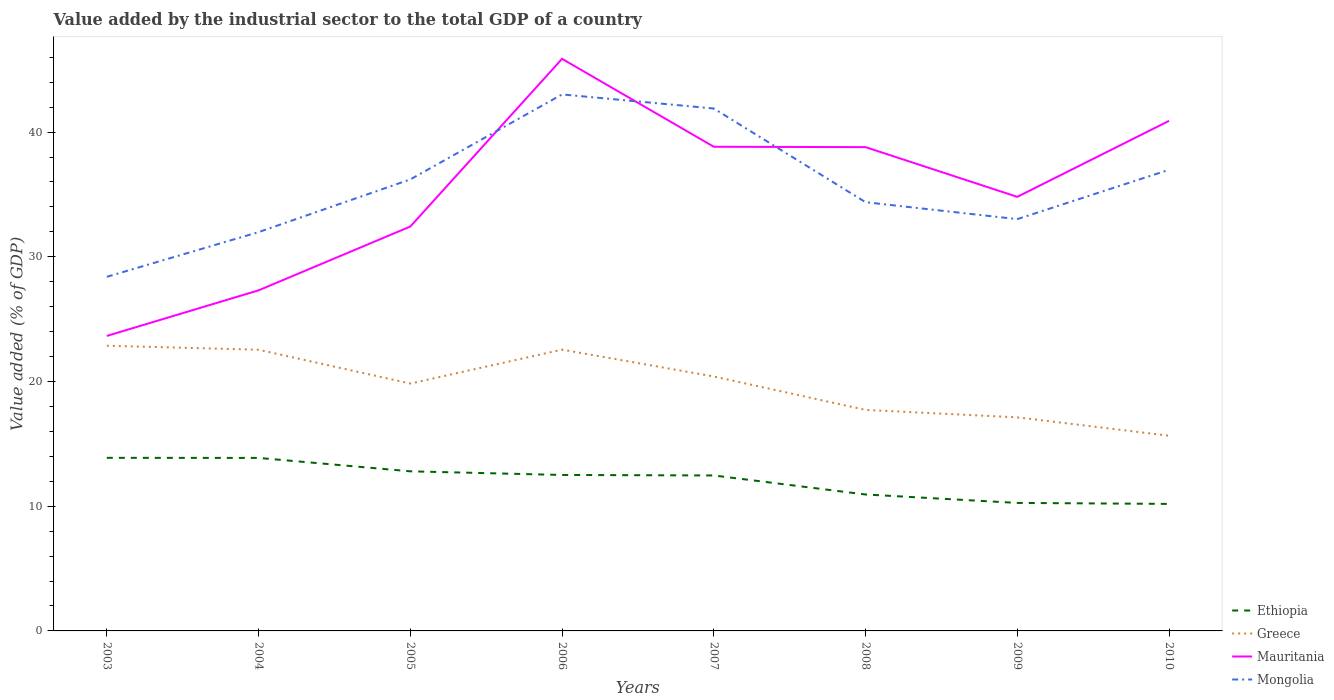Does the line corresponding to Ethiopia intersect with the line corresponding to Mauritania?
Provide a short and direct response. No. Is the number of lines equal to the number of legend labels?
Your answer should be compact. Yes. Across all years, what is the maximum value added by the industrial sector to the total GDP in Mauritania?
Provide a short and direct response. 23.66. In which year was the value added by the industrial sector to the total GDP in Mauritania maximum?
Provide a short and direct response. 2003. What is the total value added by the industrial sector to the total GDP in Greece in the graph?
Give a very brief answer. 0.31. What is the difference between the highest and the second highest value added by the industrial sector to the total GDP in Greece?
Offer a terse response. 7.21. What is the difference between two consecutive major ticks on the Y-axis?
Provide a succinct answer. 10. Does the graph contain any zero values?
Give a very brief answer. No. Where does the legend appear in the graph?
Offer a terse response. Bottom right. How many legend labels are there?
Your answer should be compact. 4. What is the title of the graph?
Ensure brevity in your answer.  Value added by the industrial sector to the total GDP of a country. Does "Romania" appear as one of the legend labels in the graph?
Offer a terse response. No. What is the label or title of the Y-axis?
Keep it short and to the point. Value added (% of GDP). What is the Value added (% of GDP) of Ethiopia in 2003?
Offer a terse response. 13.88. What is the Value added (% of GDP) of Greece in 2003?
Offer a very short reply. 22.87. What is the Value added (% of GDP) in Mauritania in 2003?
Your response must be concise. 23.66. What is the Value added (% of GDP) of Mongolia in 2003?
Provide a short and direct response. 28.4. What is the Value added (% of GDP) of Ethiopia in 2004?
Keep it short and to the point. 13.87. What is the Value added (% of GDP) in Greece in 2004?
Your answer should be very brief. 22.55. What is the Value added (% of GDP) of Mauritania in 2004?
Your answer should be compact. 27.31. What is the Value added (% of GDP) in Mongolia in 2004?
Offer a terse response. 31.98. What is the Value added (% of GDP) of Ethiopia in 2005?
Your answer should be very brief. 12.8. What is the Value added (% of GDP) in Greece in 2005?
Your response must be concise. 19.84. What is the Value added (% of GDP) in Mauritania in 2005?
Offer a very short reply. 32.43. What is the Value added (% of GDP) in Mongolia in 2005?
Offer a very short reply. 36.21. What is the Value added (% of GDP) of Ethiopia in 2006?
Your answer should be very brief. 12.51. What is the Value added (% of GDP) in Greece in 2006?
Make the answer very short. 22.56. What is the Value added (% of GDP) in Mauritania in 2006?
Ensure brevity in your answer.  45.88. What is the Value added (% of GDP) of Mongolia in 2006?
Make the answer very short. 43.02. What is the Value added (% of GDP) of Ethiopia in 2007?
Offer a very short reply. 12.47. What is the Value added (% of GDP) of Greece in 2007?
Offer a very short reply. 20.4. What is the Value added (% of GDP) in Mauritania in 2007?
Ensure brevity in your answer.  38.82. What is the Value added (% of GDP) in Mongolia in 2007?
Offer a terse response. 41.89. What is the Value added (% of GDP) of Ethiopia in 2008?
Make the answer very short. 10.94. What is the Value added (% of GDP) in Greece in 2008?
Keep it short and to the point. 17.72. What is the Value added (% of GDP) of Mauritania in 2008?
Provide a short and direct response. 38.8. What is the Value added (% of GDP) in Mongolia in 2008?
Provide a short and direct response. 34.38. What is the Value added (% of GDP) in Ethiopia in 2009?
Keep it short and to the point. 10.26. What is the Value added (% of GDP) in Greece in 2009?
Offer a very short reply. 17.13. What is the Value added (% of GDP) of Mauritania in 2009?
Offer a very short reply. 34.81. What is the Value added (% of GDP) of Mongolia in 2009?
Give a very brief answer. 33.02. What is the Value added (% of GDP) of Ethiopia in 2010?
Provide a short and direct response. 10.19. What is the Value added (% of GDP) in Greece in 2010?
Keep it short and to the point. 15.66. What is the Value added (% of GDP) in Mauritania in 2010?
Your response must be concise. 40.9. What is the Value added (% of GDP) in Mongolia in 2010?
Ensure brevity in your answer.  36.98. Across all years, what is the maximum Value added (% of GDP) of Ethiopia?
Keep it short and to the point. 13.88. Across all years, what is the maximum Value added (% of GDP) in Greece?
Provide a succinct answer. 22.87. Across all years, what is the maximum Value added (% of GDP) of Mauritania?
Offer a terse response. 45.88. Across all years, what is the maximum Value added (% of GDP) in Mongolia?
Offer a terse response. 43.02. Across all years, what is the minimum Value added (% of GDP) in Ethiopia?
Your answer should be very brief. 10.19. Across all years, what is the minimum Value added (% of GDP) of Greece?
Your answer should be very brief. 15.66. Across all years, what is the minimum Value added (% of GDP) in Mauritania?
Keep it short and to the point. 23.66. Across all years, what is the minimum Value added (% of GDP) in Mongolia?
Provide a short and direct response. 28.4. What is the total Value added (% of GDP) of Ethiopia in the graph?
Your answer should be very brief. 96.92. What is the total Value added (% of GDP) in Greece in the graph?
Make the answer very short. 158.72. What is the total Value added (% of GDP) of Mauritania in the graph?
Make the answer very short. 282.6. What is the total Value added (% of GDP) of Mongolia in the graph?
Make the answer very short. 285.88. What is the difference between the Value added (% of GDP) of Ethiopia in 2003 and that in 2004?
Your answer should be compact. 0.01. What is the difference between the Value added (% of GDP) of Greece in 2003 and that in 2004?
Your answer should be very brief. 0.32. What is the difference between the Value added (% of GDP) in Mauritania in 2003 and that in 2004?
Ensure brevity in your answer.  -3.66. What is the difference between the Value added (% of GDP) in Mongolia in 2003 and that in 2004?
Ensure brevity in your answer.  -3.58. What is the difference between the Value added (% of GDP) in Ethiopia in 2003 and that in 2005?
Provide a short and direct response. 1.08. What is the difference between the Value added (% of GDP) of Greece in 2003 and that in 2005?
Offer a terse response. 3.03. What is the difference between the Value added (% of GDP) in Mauritania in 2003 and that in 2005?
Keep it short and to the point. -8.77. What is the difference between the Value added (% of GDP) of Mongolia in 2003 and that in 2005?
Make the answer very short. -7.81. What is the difference between the Value added (% of GDP) of Ethiopia in 2003 and that in 2006?
Make the answer very short. 1.37. What is the difference between the Value added (% of GDP) of Greece in 2003 and that in 2006?
Make the answer very short. 0.31. What is the difference between the Value added (% of GDP) of Mauritania in 2003 and that in 2006?
Your response must be concise. -22.22. What is the difference between the Value added (% of GDP) in Mongolia in 2003 and that in 2006?
Your answer should be very brief. -14.62. What is the difference between the Value added (% of GDP) in Ethiopia in 2003 and that in 2007?
Your answer should be compact. 1.41. What is the difference between the Value added (% of GDP) of Greece in 2003 and that in 2007?
Provide a short and direct response. 2.47. What is the difference between the Value added (% of GDP) of Mauritania in 2003 and that in 2007?
Offer a terse response. -15.17. What is the difference between the Value added (% of GDP) in Mongolia in 2003 and that in 2007?
Offer a terse response. -13.5. What is the difference between the Value added (% of GDP) in Ethiopia in 2003 and that in 2008?
Ensure brevity in your answer.  2.94. What is the difference between the Value added (% of GDP) of Greece in 2003 and that in 2008?
Keep it short and to the point. 5.15. What is the difference between the Value added (% of GDP) in Mauritania in 2003 and that in 2008?
Your answer should be compact. -15.14. What is the difference between the Value added (% of GDP) in Mongolia in 2003 and that in 2008?
Offer a terse response. -5.98. What is the difference between the Value added (% of GDP) in Ethiopia in 2003 and that in 2009?
Offer a terse response. 3.62. What is the difference between the Value added (% of GDP) in Greece in 2003 and that in 2009?
Your answer should be compact. 5.74. What is the difference between the Value added (% of GDP) in Mauritania in 2003 and that in 2009?
Provide a succinct answer. -11.15. What is the difference between the Value added (% of GDP) of Mongolia in 2003 and that in 2009?
Your answer should be compact. -4.63. What is the difference between the Value added (% of GDP) of Ethiopia in 2003 and that in 2010?
Keep it short and to the point. 3.7. What is the difference between the Value added (% of GDP) of Greece in 2003 and that in 2010?
Ensure brevity in your answer.  7.21. What is the difference between the Value added (% of GDP) of Mauritania in 2003 and that in 2010?
Your answer should be compact. -17.25. What is the difference between the Value added (% of GDP) in Mongolia in 2003 and that in 2010?
Ensure brevity in your answer.  -8.58. What is the difference between the Value added (% of GDP) of Ethiopia in 2004 and that in 2005?
Ensure brevity in your answer.  1.07. What is the difference between the Value added (% of GDP) of Greece in 2004 and that in 2005?
Your response must be concise. 2.71. What is the difference between the Value added (% of GDP) of Mauritania in 2004 and that in 2005?
Your answer should be very brief. -5.12. What is the difference between the Value added (% of GDP) in Mongolia in 2004 and that in 2005?
Your response must be concise. -4.23. What is the difference between the Value added (% of GDP) in Ethiopia in 2004 and that in 2006?
Keep it short and to the point. 1.37. What is the difference between the Value added (% of GDP) of Greece in 2004 and that in 2006?
Provide a short and direct response. -0.01. What is the difference between the Value added (% of GDP) of Mauritania in 2004 and that in 2006?
Your answer should be very brief. -18.57. What is the difference between the Value added (% of GDP) of Mongolia in 2004 and that in 2006?
Provide a short and direct response. -11.04. What is the difference between the Value added (% of GDP) of Ethiopia in 2004 and that in 2007?
Provide a succinct answer. 1.41. What is the difference between the Value added (% of GDP) in Greece in 2004 and that in 2007?
Offer a terse response. 2.15. What is the difference between the Value added (% of GDP) of Mauritania in 2004 and that in 2007?
Provide a succinct answer. -11.51. What is the difference between the Value added (% of GDP) of Mongolia in 2004 and that in 2007?
Make the answer very short. -9.91. What is the difference between the Value added (% of GDP) in Ethiopia in 2004 and that in 2008?
Offer a very short reply. 2.93. What is the difference between the Value added (% of GDP) of Greece in 2004 and that in 2008?
Provide a succinct answer. 4.83. What is the difference between the Value added (% of GDP) in Mauritania in 2004 and that in 2008?
Offer a very short reply. -11.48. What is the difference between the Value added (% of GDP) of Mongolia in 2004 and that in 2008?
Ensure brevity in your answer.  -2.4. What is the difference between the Value added (% of GDP) of Ethiopia in 2004 and that in 2009?
Keep it short and to the point. 3.61. What is the difference between the Value added (% of GDP) of Greece in 2004 and that in 2009?
Provide a short and direct response. 5.42. What is the difference between the Value added (% of GDP) in Mauritania in 2004 and that in 2009?
Your response must be concise. -7.5. What is the difference between the Value added (% of GDP) of Mongolia in 2004 and that in 2009?
Provide a succinct answer. -1.04. What is the difference between the Value added (% of GDP) in Ethiopia in 2004 and that in 2010?
Offer a very short reply. 3.69. What is the difference between the Value added (% of GDP) in Greece in 2004 and that in 2010?
Provide a short and direct response. 6.89. What is the difference between the Value added (% of GDP) in Mauritania in 2004 and that in 2010?
Offer a terse response. -13.59. What is the difference between the Value added (% of GDP) in Mongolia in 2004 and that in 2010?
Provide a short and direct response. -5. What is the difference between the Value added (% of GDP) in Ethiopia in 2005 and that in 2006?
Provide a succinct answer. 0.29. What is the difference between the Value added (% of GDP) of Greece in 2005 and that in 2006?
Your response must be concise. -2.72. What is the difference between the Value added (% of GDP) in Mauritania in 2005 and that in 2006?
Offer a very short reply. -13.45. What is the difference between the Value added (% of GDP) in Mongolia in 2005 and that in 2006?
Your answer should be very brief. -6.81. What is the difference between the Value added (% of GDP) in Ethiopia in 2005 and that in 2007?
Ensure brevity in your answer.  0.33. What is the difference between the Value added (% of GDP) in Greece in 2005 and that in 2007?
Offer a terse response. -0.57. What is the difference between the Value added (% of GDP) of Mauritania in 2005 and that in 2007?
Offer a very short reply. -6.4. What is the difference between the Value added (% of GDP) in Mongolia in 2005 and that in 2007?
Give a very brief answer. -5.68. What is the difference between the Value added (% of GDP) in Ethiopia in 2005 and that in 2008?
Provide a short and direct response. 1.86. What is the difference between the Value added (% of GDP) in Greece in 2005 and that in 2008?
Make the answer very short. 2.11. What is the difference between the Value added (% of GDP) of Mauritania in 2005 and that in 2008?
Keep it short and to the point. -6.37. What is the difference between the Value added (% of GDP) of Mongolia in 2005 and that in 2008?
Offer a terse response. 1.83. What is the difference between the Value added (% of GDP) of Ethiopia in 2005 and that in 2009?
Your response must be concise. 2.53. What is the difference between the Value added (% of GDP) in Greece in 2005 and that in 2009?
Your response must be concise. 2.71. What is the difference between the Value added (% of GDP) of Mauritania in 2005 and that in 2009?
Give a very brief answer. -2.38. What is the difference between the Value added (% of GDP) of Mongolia in 2005 and that in 2009?
Provide a short and direct response. 3.19. What is the difference between the Value added (% of GDP) of Ethiopia in 2005 and that in 2010?
Your answer should be compact. 2.61. What is the difference between the Value added (% of GDP) in Greece in 2005 and that in 2010?
Offer a very short reply. 4.18. What is the difference between the Value added (% of GDP) in Mauritania in 2005 and that in 2010?
Offer a terse response. -8.47. What is the difference between the Value added (% of GDP) of Mongolia in 2005 and that in 2010?
Offer a very short reply. -0.77. What is the difference between the Value added (% of GDP) of Ethiopia in 2006 and that in 2007?
Make the answer very short. 0.04. What is the difference between the Value added (% of GDP) of Greece in 2006 and that in 2007?
Your answer should be compact. 2.15. What is the difference between the Value added (% of GDP) in Mauritania in 2006 and that in 2007?
Offer a very short reply. 7.05. What is the difference between the Value added (% of GDP) in Mongolia in 2006 and that in 2007?
Ensure brevity in your answer.  1.13. What is the difference between the Value added (% of GDP) of Ethiopia in 2006 and that in 2008?
Offer a terse response. 1.57. What is the difference between the Value added (% of GDP) in Greece in 2006 and that in 2008?
Make the answer very short. 4.83. What is the difference between the Value added (% of GDP) of Mauritania in 2006 and that in 2008?
Provide a short and direct response. 7.08. What is the difference between the Value added (% of GDP) in Mongolia in 2006 and that in 2008?
Ensure brevity in your answer.  8.64. What is the difference between the Value added (% of GDP) of Ethiopia in 2006 and that in 2009?
Offer a very short reply. 2.24. What is the difference between the Value added (% of GDP) of Greece in 2006 and that in 2009?
Keep it short and to the point. 5.43. What is the difference between the Value added (% of GDP) in Mauritania in 2006 and that in 2009?
Your answer should be compact. 11.07. What is the difference between the Value added (% of GDP) in Mongolia in 2006 and that in 2009?
Provide a short and direct response. 10. What is the difference between the Value added (% of GDP) of Ethiopia in 2006 and that in 2010?
Offer a terse response. 2.32. What is the difference between the Value added (% of GDP) of Greece in 2006 and that in 2010?
Offer a very short reply. 6.9. What is the difference between the Value added (% of GDP) in Mauritania in 2006 and that in 2010?
Your answer should be compact. 4.97. What is the difference between the Value added (% of GDP) of Mongolia in 2006 and that in 2010?
Offer a terse response. 6.04. What is the difference between the Value added (% of GDP) in Ethiopia in 2007 and that in 2008?
Your answer should be very brief. 1.53. What is the difference between the Value added (% of GDP) of Greece in 2007 and that in 2008?
Provide a short and direct response. 2.68. What is the difference between the Value added (% of GDP) of Mauritania in 2007 and that in 2008?
Give a very brief answer. 0.03. What is the difference between the Value added (% of GDP) of Mongolia in 2007 and that in 2008?
Keep it short and to the point. 7.51. What is the difference between the Value added (% of GDP) of Ethiopia in 2007 and that in 2009?
Offer a terse response. 2.2. What is the difference between the Value added (% of GDP) in Greece in 2007 and that in 2009?
Provide a succinct answer. 3.28. What is the difference between the Value added (% of GDP) in Mauritania in 2007 and that in 2009?
Keep it short and to the point. 4.02. What is the difference between the Value added (% of GDP) of Mongolia in 2007 and that in 2009?
Provide a succinct answer. 8.87. What is the difference between the Value added (% of GDP) in Ethiopia in 2007 and that in 2010?
Your answer should be very brief. 2.28. What is the difference between the Value added (% of GDP) in Greece in 2007 and that in 2010?
Give a very brief answer. 4.75. What is the difference between the Value added (% of GDP) in Mauritania in 2007 and that in 2010?
Your answer should be very brief. -2.08. What is the difference between the Value added (% of GDP) in Mongolia in 2007 and that in 2010?
Provide a succinct answer. 4.91. What is the difference between the Value added (% of GDP) of Ethiopia in 2008 and that in 2009?
Keep it short and to the point. 0.68. What is the difference between the Value added (% of GDP) in Greece in 2008 and that in 2009?
Offer a terse response. 0.6. What is the difference between the Value added (% of GDP) in Mauritania in 2008 and that in 2009?
Your answer should be compact. 3.99. What is the difference between the Value added (% of GDP) in Mongolia in 2008 and that in 2009?
Offer a very short reply. 1.36. What is the difference between the Value added (% of GDP) in Ethiopia in 2008 and that in 2010?
Ensure brevity in your answer.  0.76. What is the difference between the Value added (% of GDP) in Greece in 2008 and that in 2010?
Offer a very short reply. 2.07. What is the difference between the Value added (% of GDP) of Mauritania in 2008 and that in 2010?
Your answer should be compact. -2.11. What is the difference between the Value added (% of GDP) in Mongolia in 2008 and that in 2010?
Offer a terse response. -2.6. What is the difference between the Value added (% of GDP) in Ethiopia in 2009 and that in 2010?
Give a very brief answer. 0.08. What is the difference between the Value added (% of GDP) in Greece in 2009 and that in 2010?
Give a very brief answer. 1.47. What is the difference between the Value added (% of GDP) in Mauritania in 2009 and that in 2010?
Ensure brevity in your answer.  -6.1. What is the difference between the Value added (% of GDP) in Mongolia in 2009 and that in 2010?
Your answer should be compact. -3.96. What is the difference between the Value added (% of GDP) in Ethiopia in 2003 and the Value added (% of GDP) in Greece in 2004?
Ensure brevity in your answer.  -8.67. What is the difference between the Value added (% of GDP) of Ethiopia in 2003 and the Value added (% of GDP) of Mauritania in 2004?
Offer a terse response. -13.43. What is the difference between the Value added (% of GDP) of Ethiopia in 2003 and the Value added (% of GDP) of Mongolia in 2004?
Ensure brevity in your answer.  -18.1. What is the difference between the Value added (% of GDP) in Greece in 2003 and the Value added (% of GDP) in Mauritania in 2004?
Give a very brief answer. -4.44. What is the difference between the Value added (% of GDP) of Greece in 2003 and the Value added (% of GDP) of Mongolia in 2004?
Offer a terse response. -9.11. What is the difference between the Value added (% of GDP) in Mauritania in 2003 and the Value added (% of GDP) in Mongolia in 2004?
Ensure brevity in your answer.  -8.32. What is the difference between the Value added (% of GDP) in Ethiopia in 2003 and the Value added (% of GDP) in Greece in 2005?
Ensure brevity in your answer.  -5.96. What is the difference between the Value added (% of GDP) in Ethiopia in 2003 and the Value added (% of GDP) in Mauritania in 2005?
Provide a succinct answer. -18.55. What is the difference between the Value added (% of GDP) of Ethiopia in 2003 and the Value added (% of GDP) of Mongolia in 2005?
Provide a succinct answer. -22.33. What is the difference between the Value added (% of GDP) of Greece in 2003 and the Value added (% of GDP) of Mauritania in 2005?
Provide a succinct answer. -9.56. What is the difference between the Value added (% of GDP) of Greece in 2003 and the Value added (% of GDP) of Mongolia in 2005?
Give a very brief answer. -13.34. What is the difference between the Value added (% of GDP) in Mauritania in 2003 and the Value added (% of GDP) in Mongolia in 2005?
Provide a succinct answer. -12.55. What is the difference between the Value added (% of GDP) in Ethiopia in 2003 and the Value added (% of GDP) in Greece in 2006?
Give a very brief answer. -8.68. What is the difference between the Value added (% of GDP) in Ethiopia in 2003 and the Value added (% of GDP) in Mauritania in 2006?
Give a very brief answer. -32. What is the difference between the Value added (% of GDP) of Ethiopia in 2003 and the Value added (% of GDP) of Mongolia in 2006?
Your response must be concise. -29.14. What is the difference between the Value added (% of GDP) of Greece in 2003 and the Value added (% of GDP) of Mauritania in 2006?
Ensure brevity in your answer.  -23.01. What is the difference between the Value added (% of GDP) of Greece in 2003 and the Value added (% of GDP) of Mongolia in 2006?
Provide a short and direct response. -20.15. What is the difference between the Value added (% of GDP) of Mauritania in 2003 and the Value added (% of GDP) of Mongolia in 2006?
Offer a very short reply. -19.37. What is the difference between the Value added (% of GDP) in Ethiopia in 2003 and the Value added (% of GDP) in Greece in 2007?
Provide a succinct answer. -6.52. What is the difference between the Value added (% of GDP) of Ethiopia in 2003 and the Value added (% of GDP) of Mauritania in 2007?
Your answer should be very brief. -24.94. What is the difference between the Value added (% of GDP) of Ethiopia in 2003 and the Value added (% of GDP) of Mongolia in 2007?
Your answer should be very brief. -28.01. What is the difference between the Value added (% of GDP) in Greece in 2003 and the Value added (% of GDP) in Mauritania in 2007?
Keep it short and to the point. -15.96. What is the difference between the Value added (% of GDP) in Greece in 2003 and the Value added (% of GDP) in Mongolia in 2007?
Your answer should be compact. -19.02. What is the difference between the Value added (% of GDP) in Mauritania in 2003 and the Value added (% of GDP) in Mongolia in 2007?
Ensure brevity in your answer.  -18.24. What is the difference between the Value added (% of GDP) in Ethiopia in 2003 and the Value added (% of GDP) in Greece in 2008?
Keep it short and to the point. -3.84. What is the difference between the Value added (% of GDP) of Ethiopia in 2003 and the Value added (% of GDP) of Mauritania in 2008?
Your answer should be compact. -24.92. What is the difference between the Value added (% of GDP) of Ethiopia in 2003 and the Value added (% of GDP) of Mongolia in 2008?
Your response must be concise. -20.5. What is the difference between the Value added (% of GDP) of Greece in 2003 and the Value added (% of GDP) of Mauritania in 2008?
Provide a short and direct response. -15.93. What is the difference between the Value added (% of GDP) in Greece in 2003 and the Value added (% of GDP) in Mongolia in 2008?
Your answer should be compact. -11.51. What is the difference between the Value added (% of GDP) in Mauritania in 2003 and the Value added (% of GDP) in Mongolia in 2008?
Your answer should be very brief. -10.72. What is the difference between the Value added (% of GDP) of Ethiopia in 2003 and the Value added (% of GDP) of Greece in 2009?
Keep it short and to the point. -3.25. What is the difference between the Value added (% of GDP) in Ethiopia in 2003 and the Value added (% of GDP) in Mauritania in 2009?
Ensure brevity in your answer.  -20.93. What is the difference between the Value added (% of GDP) in Ethiopia in 2003 and the Value added (% of GDP) in Mongolia in 2009?
Offer a very short reply. -19.14. What is the difference between the Value added (% of GDP) of Greece in 2003 and the Value added (% of GDP) of Mauritania in 2009?
Your answer should be compact. -11.94. What is the difference between the Value added (% of GDP) in Greece in 2003 and the Value added (% of GDP) in Mongolia in 2009?
Provide a short and direct response. -10.15. What is the difference between the Value added (% of GDP) in Mauritania in 2003 and the Value added (% of GDP) in Mongolia in 2009?
Make the answer very short. -9.37. What is the difference between the Value added (% of GDP) in Ethiopia in 2003 and the Value added (% of GDP) in Greece in 2010?
Make the answer very short. -1.78. What is the difference between the Value added (% of GDP) in Ethiopia in 2003 and the Value added (% of GDP) in Mauritania in 2010?
Give a very brief answer. -27.02. What is the difference between the Value added (% of GDP) in Ethiopia in 2003 and the Value added (% of GDP) in Mongolia in 2010?
Your response must be concise. -23.1. What is the difference between the Value added (% of GDP) of Greece in 2003 and the Value added (% of GDP) of Mauritania in 2010?
Provide a short and direct response. -18.04. What is the difference between the Value added (% of GDP) of Greece in 2003 and the Value added (% of GDP) of Mongolia in 2010?
Ensure brevity in your answer.  -14.11. What is the difference between the Value added (% of GDP) in Mauritania in 2003 and the Value added (% of GDP) in Mongolia in 2010?
Give a very brief answer. -13.32. What is the difference between the Value added (% of GDP) of Ethiopia in 2004 and the Value added (% of GDP) of Greece in 2005?
Your answer should be very brief. -5.96. What is the difference between the Value added (% of GDP) of Ethiopia in 2004 and the Value added (% of GDP) of Mauritania in 2005?
Give a very brief answer. -18.56. What is the difference between the Value added (% of GDP) in Ethiopia in 2004 and the Value added (% of GDP) in Mongolia in 2005?
Make the answer very short. -22.33. What is the difference between the Value added (% of GDP) in Greece in 2004 and the Value added (% of GDP) in Mauritania in 2005?
Your answer should be compact. -9.88. What is the difference between the Value added (% of GDP) of Greece in 2004 and the Value added (% of GDP) of Mongolia in 2005?
Your answer should be very brief. -13.66. What is the difference between the Value added (% of GDP) in Mauritania in 2004 and the Value added (% of GDP) in Mongolia in 2005?
Ensure brevity in your answer.  -8.9. What is the difference between the Value added (% of GDP) in Ethiopia in 2004 and the Value added (% of GDP) in Greece in 2006?
Your answer should be very brief. -8.68. What is the difference between the Value added (% of GDP) in Ethiopia in 2004 and the Value added (% of GDP) in Mauritania in 2006?
Your answer should be compact. -32. What is the difference between the Value added (% of GDP) in Ethiopia in 2004 and the Value added (% of GDP) in Mongolia in 2006?
Give a very brief answer. -29.15. What is the difference between the Value added (% of GDP) of Greece in 2004 and the Value added (% of GDP) of Mauritania in 2006?
Offer a very short reply. -23.33. What is the difference between the Value added (% of GDP) in Greece in 2004 and the Value added (% of GDP) in Mongolia in 2006?
Provide a succinct answer. -20.47. What is the difference between the Value added (% of GDP) in Mauritania in 2004 and the Value added (% of GDP) in Mongolia in 2006?
Your answer should be very brief. -15.71. What is the difference between the Value added (% of GDP) of Ethiopia in 2004 and the Value added (% of GDP) of Greece in 2007?
Provide a succinct answer. -6.53. What is the difference between the Value added (% of GDP) of Ethiopia in 2004 and the Value added (% of GDP) of Mauritania in 2007?
Provide a short and direct response. -24.95. What is the difference between the Value added (% of GDP) of Ethiopia in 2004 and the Value added (% of GDP) of Mongolia in 2007?
Offer a terse response. -28.02. What is the difference between the Value added (% of GDP) of Greece in 2004 and the Value added (% of GDP) of Mauritania in 2007?
Make the answer very short. -16.28. What is the difference between the Value added (% of GDP) in Greece in 2004 and the Value added (% of GDP) in Mongolia in 2007?
Provide a succinct answer. -19.34. What is the difference between the Value added (% of GDP) in Mauritania in 2004 and the Value added (% of GDP) in Mongolia in 2007?
Make the answer very short. -14.58. What is the difference between the Value added (% of GDP) of Ethiopia in 2004 and the Value added (% of GDP) of Greece in 2008?
Your answer should be compact. -3.85. What is the difference between the Value added (% of GDP) of Ethiopia in 2004 and the Value added (% of GDP) of Mauritania in 2008?
Give a very brief answer. -24.92. What is the difference between the Value added (% of GDP) of Ethiopia in 2004 and the Value added (% of GDP) of Mongolia in 2008?
Offer a terse response. -20.51. What is the difference between the Value added (% of GDP) in Greece in 2004 and the Value added (% of GDP) in Mauritania in 2008?
Ensure brevity in your answer.  -16.25. What is the difference between the Value added (% of GDP) of Greece in 2004 and the Value added (% of GDP) of Mongolia in 2008?
Your answer should be compact. -11.83. What is the difference between the Value added (% of GDP) in Mauritania in 2004 and the Value added (% of GDP) in Mongolia in 2008?
Offer a very short reply. -7.07. What is the difference between the Value added (% of GDP) of Ethiopia in 2004 and the Value added (% of GDP) of Greece in 2009?
Ensure brevity in your answer.  -3.25. What is the difference between the Value added (% of GDP) in Ethiopia in 2004 and the Value added (% of GDP) in Mauritania in 2009?
Your answer should be compact. -20.94. What is the difference between the Value added (% of GDP) in Ethiopia in 2004 and the Value added (% of GDP) in Mongolia in 2009?
Your answer should be compact. -19.15. What is the difference between the Value added (% of GDP) in Greece in 2004 and the Value added (% of GDP) in Mauritania in 2009?
Your answer should be compact. -12.26. What is the difference between the Value added (% of GDP) of Greece in 2004 and the Value added (% of GDP) of Mongolia in 2009?
Offer a terse response. -10.47. What is the difference between the Value added (% of GDP) of Mauritania in 2004 and the Value added (% of GDP) of Mongolia in 2009?
Provide a succinct answer. -5.71. What is the difference between the Value added (% of GDP) in Ethiopia in 2004 and the Value added (% of GDP) in Greece in 2010?
Your answer should be compact. -1.78. What is the difference between the Value added (% of GDP) of Ethiopia in 2004 and the Value added (% of GDP) of Mauritania in 2010?
Provide a short and direct response. -27.03. What is the difference between the Value added (% of GDP) in Ethiopia in 2004 and the Value added (% of GDP) in Mongolia in 2010?
Your response must be concise. -23.1. What is the difference between the Value added (% of GDP) in Greece in 2004 and the Value added (% of GDP) in Mauritania in 2010?
Provide a short and direct response. -18.35. What is the difference between the Value added (% of GDP) of Greece in 2004 and the Value added (% of GDP) of Mongolia in 2010?
Provide a short and direct response. -14.43. What is the difference between the Value added (% of GDP) of Mauritania in 2004 and the Value added (% of GDP) of Mongolia in 2010?
Offer a terse response. -9.67. What is the difference between the Value added (% of GDP) in Ethiopia in 2005 and the Value added (% of GDP) in Greece in 2006?
Provide a short and direct response. -9.76. What is the difference between the Value added (% of GDP) in Ethiopia in 2005 and the Value added (% of GDP) in Mauritania in 2006?
Make the answer very short. -33.08. What is the difference between the Value added (% of GDP) in Ethiopia in 2005 and the Value added (% of GDP) in Mongolia in 2006?
Ensure brevity in your answer.  -30.22. What is the difference between the Value added (% of GDP) of Greece in 2005 and the Value added (% of GDP) of Mauritania in 2006?
Your response must be concise. -26.04. What is the difference between the Value added (% of GDP) of Greece in 2005 and the Value added (% of GDP) of Mongolia in 2006?
Provide a succinct answer. -23.18. What is the difference between the Value added (% of GDP) of Mauritania in 2005 and the Value added (% of GDP) of Mongolia in 2006?
Your response must be concise. -10.59. What is the difference between the Value added (% of GDP) of Ethiopia in 2005 and the Value added (% of GDP) of Greece in 2007?
Make the answer very short. -7.6. What is the difference between the Value added (% of GDP) of Ethiopia in 2005 and the Value added (% of GDP) of Mauritania in 2007?
Provide a succinct answer. -26.03. What is the difference between the Value added (% of GDP) in Ethiopia in 2005 and the Value added (% of GDP) in Mongolia in 2007?
Provide a succinct answer. -29.09. What is the difference between the Value added (% of GDP) of Greece in 2005 and the Value added (% of GDP) of Mauritania in 2007?
Ensure brevity in your answer.  -18.99. What is the difference between the Value added (% of GDP) of Greece in 2005 and the Value added (% of GDP) of Mongolia in 2007?
Give a very brief answer. -22.05. What is the difference between the Value added (% of GDP) of Mauritania in 2005 and the Value added (% of GDP) of Mongolia in 2007?
Keep it short and to the point. -9.46. What is the difference between the Value added (% of GDP) in Ethiopia in 2005 and the Value added (% of GDP) in Greece in 2008?
Make the answer very short. -4.92. What is the difference between the Value added (% of GDP) of Ethiopia in 2005 and the Value added (% of GDP) of Mauritania in 2008?
Offer a very short reply. -26. What is the difference between the Value added (% of GDP) of Ethiopia in 2005 and the Value added (% of GDP) of Mongolia in 2008?
Your answer should be compact. -21.58. What is the difference between the Value added (% of GDP) in Greece in 2005 and the Value added (% of GDP) in Mauritania in 2008?
Offer a terse response. -18.96. What is the difference between the Value added (% of GDP) in Greece in 2005 and the Value added (% of GDP) in Mongolia in 2008?
Provide a short and direct response. -14.54. What is the difference between the Value added (% of GDP) in Mauritania in 2005 and the Value added (% of GDP) in Mongolia in 2008?
Your response must be concise. -1.95. What is the difference between the Value added (% of GDP) of Ethiopia in 2005 and the Value added (% of GDP) of Greece in 2009?
Your response must be concise. -4.33. What is the difference between the Value added (% of GDP) of Ethiopia in 2005 and the Value added (% of GDP) of Mauritania in 2009?
Your answer should be compact. -22.01. What is the difference between the Value added (% of GDP) in Ethiopia in 2005 and the Value added (% of GDP) in Mongolia in 2009?
Your response must be concise. -20.22. What is the difference between the Value added (% of GDP) of Greece in 2005 and the Value added (% of GDP) of Mauritania in 2009?
Make the answer very short. -14.97. What is the difference between the Value added (% of GDP) of Greece in 2005 and the Value added (% of GDP) of Mongolia in 2009?
Provide a succinct answer. -13.18. What is the difference between the Value added (% of GDP) of Mauritania in 2005 and the Value added (% of GDP) of Mongolia in 2009?
Offer a terse response. -0.59. What is the difference between the Value added (% of GDP) of Ethiopia in 2005 and the Value added (% of GDP) of Greece in 2010?
Offer a very short reply. -2.86. What is the difference between the Value added (% of GDP) in Ethiopia in 2005 and the Value added (% of GDP) in Mauritania in 2010?
Give a very brief answer. -28.1. What is the difference between the Value added (% of GDP) in Ethiopia in 2005 and the Value added (% of GDP) in Mongolia in 2010?
Give a very brief answer. -24.18. What is the difference between the Value added (% of GDP) in Greece in 2005 and the Value added (% of GDP) in Mauritania in 2010?
Ensure brevity in your answer.  -21.07. What is the difference between the Value added (% of GDP) in Greece in 2005 and the Value added (% of GDP) in Mongolia in 2010?
Your answer should be compact. -17.14. What is the difference between the Value added (% of GDP) of Mauritania in 2005 and the Value added (% of GDP) of Mongolia in 2010?
Keep it short and to the point. -4.55. What is the difference between the Value added (% of GDP) of Ethiopia in 2006 and the Value added (% of GDP) of Greece in 2007?
Your answer should be very brief. -7.9. What is the difference between the Value added (% of GDP) of Ethiopia in 2006 and the Value added (% of GDP) of Mauritania in 2007?
Provide a short and direct response. -26.32. What is the difference between the Value added (% of GDP) of Ethiopia in 2006 and the Value added (% of GDP) of Mongolia in 2007?
Offer a very short reply. -29.39. What is the difference between the Value added (% of GDP) in Greece in 2006 and the Value added (% of GDP) in Mauritania in 2007?
Your answer should be compact. -16.27. What is the difference between the Value added (% of GDP) in Greece in 2006 and the Value added (% of GDP) in Mongolia in 2007?
Offer a very short reply. -19.34. What is the difference between the Value added (% of GDP) of Mauritania in 2006 and the Value added (% of GDP) of Mongolia in 2007?
Your response must be concise. 3.98. What is the difference between the Value added (% of GDP) in Ethiopia in 2006 and the Value added (% of GDP) in Greece in 2008?
Your answer should be compact. -5.22. What is the difference between the Value added (% of GDP) of Ethiopia in 2006 and the Value added (% of GDP) of Mauritania in 2008?
Provide a short and direct response. -26.29. What is the difference between the Value added (% of GDP) of Ethiopia in 2006 and the Value added (% of GDP) of Mongolia in 2008?
Make the answer very short. -21.87. What is the difference between the Value added (% of GDP) of Greece in 2006 and the Value added (% of GDP) of Mauritania in 2008?
Offer a very short reply. -16.24. What is the difference between the Value added (% of GDP) in Greece in 2006 and the Value added (% of GDP) in Mongolia in 2008?
Offer a terse response. -11.82. What is the difference between the Value added (% of GDP) in Mauritania in 2006 and the Value added (% of GDP) in Mongolia in 2008?
Offer a terse response. 11.5. What is the difference between the Value added (% of GDP) of Ethiopia in 2006 and the Value added (% of GDP) of Greece in 2009?
Your answer should be compact. -4.62. What is the difference between the Value added (% of GDP) of Ethiopia in 2006 and the Value added (% of GDP) of Mauritania in 2009?
Your answer should be very brief. -22.3. What is the difference between the Value added (% of GDP) in Ethiopia in 2006 and the Value added (% of GDP) in Mongolia in 2009?
Your response must be concise. -20.51. What is the difference between the Value added (% of GDP) in Greece in 2006 and the Value added (% of GDP) in Mauritania in 2009?
Keep it short and to the point. -12.25. What is the difference between the Value added (% of GDP) in Greece in 2006 and the Value added (% of GDP) in Mongolia in 2009?
Offer a very short reply. -10.47. What is the difference between the Value added (% of GDP) in Mauritania in 2006 and the Value added (% of GDP) in Mongolia in 2009?
Offer a very short reply. 12.85. What is the difference between the Value added (% of GDP) of Ethiopia in 2006 and the Value added (% of GDP) of Greece in 2010?
Your response must be concise. -3.15. What is the difference between the Value added (% of GDP) in Ethiopia in 2006 and the Value added (% of GDP) in Mauritania in 2010?
Offer a terse response. -28.4. What is the difference between the Value added (% of GDP) of Ethiopia in 2006 and the Value added (% of GDP) of Mongolia in 2010?
Provide a short and direct response. -24.47. What is the difference between the Value added (% of GDP) of Greece in 2006 and the Value added (% of GDP) of Mauritania in 2010?
Make the answer very short. -18.35. What is the difference between the Value added (% of GDP) in Greece in 2006 and the Value added (% of GDP) in Mongolia in 2010?
Ensure brevity in your answer.  -14.42. What is the difference between the Value added (% of GDP) of Mauritania in 2006 and the Value added (% of GDP) of Mongolia in 2010?
Provide a succinct answer. 8.9. What is the difference between the Value added (% of GDP) in Ethiopia in 2007 and the Value added (% of GDP) in Greece in 2008?
Make the answer very short. -5.26. What is the difference between the Value added (% of GDP) of Ethiopia in 2007 and the Value added (% of GDP) of Mauritania in 2008?
Offer a very short reply. -26.33. What is the difference between the Value added (% of GDP) in Ethiopia in 2007 and the Value added (% of GDP) in Mongolia in 2008?
Ensure brevity in your answer.  -21.91. What is the difference between the Value added (% of GDP) of Greece in 2007 and the Value added (% of GDP) of Mauritania in 2008?
Your answer should be compact. -18.39. What is the difference between the Value added (% of GDP) in Greece in 2007 and the Value added (% of GDP) in Mongolia in 2008?
Make the answer very short. -13.98. What is the difference between the Value added (% of GDP) in Mauritania in 2007 and the Value added (% of GDP) in Mongolia in 2008?
Give a very brief answer. 4.45. What is the difference between the Value added (% of GDP) of Ethiopia in 2007 and the Value added (% of GDP) of Greece in 2009?
Offer a terse response. -4.66. What is the difference between the Value added (% of GDP) of Ethiopia in 2007 and the Value added (% of GDP) of Mauritania in 2009?
Give a very brief answer. -22.34. What is the difference between the Value added (% of GDP) of Ethiopia in 2007 and the Value added (% of GDP) of Mongolia in 2009?
Your answer should be very brief. -20.56. What is the difference between the Value added (% of GDP) in Greece in 2007 and the Value added (% of GDP) in Mauritania in 2009?
Your answer should be compact. -14.41. What is the difference between the Value added (% of GDP) in Greece in 2007 and the Value added (% of GDP) in Mongolia in 2009?
Give a very brief answer. -12.62. What is the difference between the Value added (% of GDP) in Mauritania in 2007 and the Value added (% of GDP) in Mongolia in 2009?
Your response must be concise. 5.8. What is the difference between the Value added (% of GDP) of Ethiopia in 2007 and the Value added (% of GDP) of Greece in 2010?
Provide a succinct answer. -3.19. What is the difference between the Value added (% of GDP) of Ethiopia in 2007 and the Value added (% of GDP) of Mauritania in 2010?
Provide a succinct answer. -28.44. What is the difference between the Value added (% of GDP) in Ethiopia in 2007 and the Value added (% of GDP) in Mongolia in 2010?
Your response must be concise. -24.51. What is the difference between the Value added (% of GDP) of Greece in 2007 and the Value added (% of GDP) of Mauritania in 2010?
Your answer should be compact. -20.5. What is the difference between the Value added (% of GDP) of Greece in 2007 and the Value added (% of GDP) of Mongolia in 2010?
Your answer should be compact. -16.57. What is the difference between the Value added (% of GDP) in Mauritania in 2007 and the Value added (% of GDP) in Mongolia in 2010?
Make the answer very short. 1.85. What is the difference between the Value added (% of GDP) of Ethiopia in 2008 and the Value added (% of GDP) of Greece in 2009?
Your answer should be compact. -6.19. What is the difference between the Value added (% of GDP) in Ethiopia in 2008 and the Value added (% of GDP) in Mauritania in 2009?
Your answer should be compact. -23.87. What is the difference between the Value added (% of GDP) of Ethiopia in 2008 and the Value added (% of GDP) of Mongolia in 2009?
Your response must be concise. -22.08. What is the difference between the Value added (% of GDP) of Greece in 2008 and the Value added (% of GDP) of Mauritania in 2009?
Offer a very short reply. -17.09. What is the difference between the Value added (% of GDP) of Greece in 2008 and the Value added (% of GDP) of Mongolia in 2009?
Your answer should be compact. -15.3. What is the difference between the Value added (% of GDP) of Mauritania in 2008 and the Value added (% of GDP) of Mongolia in 2009?
Offer a very short reply. 5.77. What is the difference between the Value added (% of GDP) in Ethiopia in 2008 and the Value added (% of GDP) in Greece in 2010?
Your response must be concise. -4.71. What is the difference between the Value added (% of GDP) in Ethiopia in 2008 and the Value added (% of GDP) in Mauritania in 2010?
Your response must be concise. -29.96. What is the difference between the Value added (% of GDP) in Ethiopia in 2008 and the Value added (% of GDP) in Mongolia in 2010?
Provide a short and direct response. -26.04. What is the difference between the Value added (% of GDP) in Greece in 2008 and the Value added (% of GDP) in Mauritania in 2010?
Offer a very short reply. -23.18. What is the difference between the Value added (% of GDP) of Greece in 2008 and the Value added (% of GDP) of Mongolia in 2010?
Provide a succinct answer. -19.26. What is the difference between the Value added (% of GDP) of Mauritania in 2008 and the Value added (% of GDP) of Mongolia in 2010?
Offer a very short reply. 1.82. What is the difference between the Value added (% of GDP) in Ethiopia in 2009 and the Value added (% of GDP) in Greece in 2010?
Make the answer very short. -5.39. What is the difference between the Value added (% of GDP) in Ethiopia in 2009 and the Value added (% of GDP) in Mauritania in 2010?
Your response must be concise. -30.64. What is the difference between the Value added (% of GDP) in Ethiopia in 2009 and the Value added (% of GDP) in Mongolia in 2010?
Give a very brief answer. -26.71. What is the difference between the Value added (% of GDP) of Greece in 2009 and the Value added (% of GDP) of Mauritania in 2010?
Offer a very short reply. -23.78. What is the difference between the Value added (% of GDP) of Greece in 2009 and the Value added (% of GDP) of Mongolia in 2010?
Your answer should be compact. -19.85. What is the difference between the Value added (% of GDP) in Mauritania in 2009 and the Value added (% of GDP) in Mongolia in 2010?
Offer a terse response. -2.17. What is the average Value added (% of GDP) of Ethiopia per year?
Offer a terse response. 12.11. What is the average Value added (% of GDP) in Greece per year?
Your answer should be very brief. 19.84. What is the average Value added (% of GDP) in Mauritania per year?
Offer a terse response. 35.33. What is the average Value added (% of GDP) of Mongolia per year?
Keep it short and to the point. 35.73. In the year 2003, what is the difference between the Value added (% of GDP) in Ethiopia and Value added (% of GDP) in Greece?
Give a very brief answer. -8.99. In the year 2003, what is the difference between the Value added (% of GDP) of Ethiopia and Value added (% of GDP) of Mauritania?
Ensure brevity in your answer.  -9.78. In the year 2003, what is the difference between the Value added (% of GDP) of Ethiopia and Value added (% of GDP) of Mongolia?
Make the answer very short. -14.52. In the year 2003, what is the difference between the Value added (% of GDP) of Greece and Value added (% of GDP) of Mauritania?
Offer a very short reply. -0.79. In the year 2003, what is the difference between the Value added (% of GDP) of Greece and Value added (% of GDP) of Mongolia?
Offer a very short reply. -5.53. In the year 2003, what is the difference between the Value added (% of GDP) of Mauritania and Value added (% of GDP) of Mongolia?
Ensure brevity in your answer.  -4.74. In the year 2004, what is the difference between the Value added (% of GDP) in Ethiopia and Value added (% of GDP) in Greece?
Give a very brief answer. -8.68. In the year 2004, what is the difference between the Value added (% of GDP) of Ethiopia and Value added (% of GDP) of Mauritania?
Ensure brevity in your answer.  -13.44. In the year 2004, what is the difference between the Value added (% of GDP) of Ethiopia and Value added (% of GDP) of Mongolia?
Provide a short and direct response. -18.11. In the year 2004, what is the difference between the Value added (% of GDP) of Greece and Value added (% of GDP) of Mauritania?
Keep it short and to the point. -4.76. In the year 2004, what is the difference between the Value added (% of GDP) in Greece and Value added (% of GDP) in Mongolia?
Your response must be concise. -9.43. In the year 2004, what is the difference between the Value added (% of GDP) in Mauritania and Value added (% of GDP) in Mongolia?
Give a very brief answer. -4.67. In the year 2005, what is the difference between the Value added (% of GDP) of Ethiopia and Value added (% of GDP) of Greece?
Your answer should be very brief. -7.04. In the year 2005, what is the difference between the Value added (% of GDP) of Ethiopia and Value added (% of GDP) of Mauritania?
Ensure brevity in your answer.  -19.63. In the year 2005, what is the difference between the Value added (% of GDP) in Ethiopia and Value added (% of GDP) in Mongolia?
Your response must be concise. -23.41. In the year 2005, what is the difference between the Value added (% of GDP) of Greece and Value added (% of GDP) of Mauritania?
Offer a very short reply. -12.59. In the year 2005, what is the difference between the Value added (% of GDP) of Greece and Value added (% of GDP) of Mongolia?
Make the answer very short. -16.37. In the year 2005, what is the difference between the Value added (% of GDP) in Mauritania and Value added (% of GDP) in Mongolia?
Make the answer very short. -3.78. In the year 2006, what is the difference between the Value added (% of GDP) in Ethiopia and Value added (% of GDP) in Greece?
Make the answer very short. -10.05. In the year 2006, what is the difference between the Value added (% of GDP) in Ethiopia and Value added (% of GDP) in Mauritania?
Your answer should be compact. -33.37. In the year 2006, what is the difference between the Value added (% of GDP) of Ethiopia and Value added (% of GDP) of Mongolia?
Give a very brief answer. -30.51. In the year 2006, what is the difference between the Value added (% of GDP) in Greece and Value added (% of GDP) in Mauritania?
Offer a terse response. -23.32. In the year 2006, what is the difference between the Value added (% of GDP) of Greece and Value added (% of GDP) of Mongolia?
Offer a terse response. -20.46. In the year 2006, what is the difference between the Value added (% of GDP) of Mauritania and Value added (% of GDP) of Mongolia?
Ensure brevity in your answer.  2.85. In the year 2007, what is the difference between the Value added (% of GDP) in Ethiopia and Value added (% of GDP) in Greece?
Make the answer very short. -7.94. In the year 2007, what is the difference between the Value added (% of GDP) in Ethiopia and Value added (% of GDP) in Mauritania?
Provide a short and direct response. -26.36. In the year 2007, what is the difference between the Value added (% of GDP) in Ethiopia and Value added (% of GDP) in Mongolia?
Keep it short and to the point. -29.43. In the year 2007, what is the difference between the Value added (% of GDP) in Greece and Value added (% of GDP) in Mauritania?
Provide a succinct answer. -18.42. In the year 2007, what is the difference between the Value added (% of GDP) of Greece and Value added (% of GDP) of Mongolia?
Your answer should be very brief. -21.49. In the year 2007, what is the difference between the Value added (% of GDP) in Mauritania and Value added (% of GDP) in Mongolia?
Provide a short and direct response. -3.07. In the year 2008, what is the difference between the Value added (% of GDP) in Ethiopia and Value added (% of GDP) in Greece?
Provide a short and direct response. -6.78. In the year 2008, what is the difference between the Value added (% of GDP) in Ethiopia and Value added (% of GDP) in Mauritania?
Make the answer very short. -27.85. In the year 2008, what is the difference between the Value added (% of GDP) of Ethiopia and Value added (% of GDP) of Mongolia?
Offer a terse response. -23.44. In the year 2008, what is the difference between the Value added (% of GDP) in Greece and Value added (% of GDP) in Mauritania?
Your answer should be compact. -21.07. In the year 2008, what is the difference between the Value added (% of GDP) of Greece and Value added (% of GDP) of Mongolia?
Ensure brevity in your answer.  -16.66. In the year 2008, what is the difference between the Value added (% of GDP) of Mauritania and Value added (% of GDP) of Mongolia?
Offer a terse response. 4.42. In the year 2009, what is the difference between the Value added (% of GDP) in Ethiopia and Value added (% of GDP) in Greece?
Give a very brief answer. -6.86. In the year 2009, what is the difference between the Value added (% of GDP) in Ethiopia and Value added (% of GDP) in Mauritania?
Your answer should be very brief. -24.54. In the year 2009, what is the difference between the Value added (% of GDP) in Ethiopia and Value added (% of GDP) in Mongolia?
Keep it short and to the point. -22.76. In the year 2009, what is the difference between the Value added (% of GDP) in Greece and Value added (% of GDP) in Mauritania?
Offer a terse response. -17.68. In the year 2009, what is the difference between the Value added (% of GDP) of Greece and Value added (% of GDP) of Mongolia?
Your answer should be compact. -15.9. In the year 2009, what is the difference between the Value added (% of GDP) in Mauritania and Value added (% of GDP) in Mongolia?
Make the answer very short. 1.79. In the year 2010, what is the difference between the Value added (% of GDP) of Ethiopia and Value added (% of GDP) of Greece?
Offer a very short reply. -5.47. In the year 2010, what is the difference between the Value added (% of GDP) of Ethiopia and Value added (% of GDP) of Mauritania?
Your answer should be compact. -30.72. In the year 2010, what is the difference between the Value added (% of GDP) of Ethiopia and Value added (% of GDP) of Mongolia?
Your response must be concise. -26.79. In the year 2010, what is the difference between the Value added (% of GDP) of Greece and Value added (% of GDP) of Mauritania?
Provide a succinct answer. -25.25. In the year 2010, what is the difference between the Value added (% of GDP) of Greece and Value added (% of GDP) of Mongolia?
Give a very brief answer. -21.32. In the year 2010, what is the difference between the Value added (% of GDP) of Mauritania and Value added (% of GDP) of Mongolia?
Give a very brief answer. 3.93. What is the ratio of the Value added (% of GDP) of Greece in 2003 to that in 2004?
Offer a very short reply. 1.01. What is the ratio of the Value added (% of GDP) in Mauritania in 2003 to that in 2004?
Ensure brevity in your answer.  0.87. What is the ratio of the Value added (% of GDP) of Mongolia in 2003 to that in 2004?
Make the answer very short. 0.89. What is the ratio of the Value added (% of GDP) of Ethiopia in 2003 to that in 2005?
Provide a short and direct response. 1.08. What is the ratio of the Value added (% of GDP) of Greece in 2003 to that in 2005?
Provide a short and direct response. 1.15. What is the ratio of the Value added (% of GDP) in Mauritania in 2003 to that in 2005?
Your response must be concise. 0.73. What is the ratio of the Value added (% of GDP) in Mongolia in 2003 to that in 2005?
Your answer should be compact. 0.78. What is the ratio of the Value added (% of GDP) in Ethiopia in 2003 to that in 2006?
Offer a very short reply. 1.11. What is the ratio of the Value added (% of GDP) in Greece in 2003 to that in 2006?
Your answer should be compact. 1.01. What is the ratio of the Value added (% of GDP) of Mauritania in 2003 to that in 2006?
Your answer should be compact. 0.52. What is the ratio of the Value added (% of GDP) in Mongolia in 2003 to that in 2006?
Provide a succinct answer. 0.66. What is the ratio of the Value added (% of GDP) of Ethiopia in 2003 to that in 2007?
Your answer should be very brief. 1.11. What is the ratio of the Value added (% of GDP) of Greece in 2003 to that in 2007?
Keep it short and to the point. 1.12. What is the ratio of the Value added (% of GDP) of Mauritania in 2003 to that in 2007?
Your answer should be compact. 0.61. What is the ratio of the Value added (% of GDP) in Mongolia in 2003 to that in 2007?
Ensure brevity in your answer.  0.68. What is the ratio of the Value added (% of GDP) of Ethiopia in 2003 to that in 2008?
Keep it short and to the point. 1.27. What is the ratio of the Value added (% of GDP) in Greece in 2003 to that in 2008?
Offer a terse response. 1.29. What is the ratio of the Value added (% of GDP) in Mauritania in 2003 to that in 2008?
Offer a terse response. 0.61. What is the ratio of the Value added (% of GDP) of Mongolia in 2003 to that in 2008?
Ensure brevity in your answer.  0.83. What is the ratio of the Value added (% of GDP) in Ethiopia in 2003 to that in 2009?
Provide a short and direct response. 1.35. What is the ratio of the Value added (% of GDP) in Greece in 2003 to that in 2009?
Make the answer very short. 1.34. What is the ratio of the Value added (% of GDP) in Mauritania in 2003 to that in 2009?
Provide a short and direct response. 0.68. What is the ratio of the Value added (% of GDP) in Mongolia in 2003 to that in 2009?
Offer a terse response. 0.86. What is the ratio of the Value added (% of GDP) of Ethiopia in 2003 to that in 2010?
Offer a very short reply. 1.36. What is the ratio of the Value added (% of GDP) of Greece in 2003 to that in 2010?
Keep it short and to the point. 1.46. What is the ratio of the Value added (% of GDP) in Mauritania in 2003 to that in 2010?
Ensure brevity in your answer.  0.58. What is the ratio of the Value added (% of GDP) in Mongolia in 2003 to that in 2010?
Your answer should be compact. 0.77. What is the ratio of the Value added (% of GDP) in Ethiopia in 2004 to that in 2005?
Make the answer very short. 1.08. What is the ratio of the Value added (% of GDP) of Greece in 2004 to that in 2005?
Your answer should be compact. 1.14. What is the ratio of the Value added (% of GDP) in Mauritania in 2004 to that in 2005?
Provide a short and direct response. 0.84. What is the ratio of the Value added (% of GDP) in Mongolia in 2004 to that in 2005?
Give a very brief answer. 0.88. What is the ratio of the Value added (% of GDP) in Ethiopia in 2004 to that in 2006?
Provide a short and direct response. 1.11. What is the ratio of the Value added (% of GDP) in Greece in 2004 to that in 2006?
Your answer should be very brief. 1. What is the ratio of the Value added (% of GDP) of Mauritania in 2004 to that in 2006?
Your answer should be very brief. 0.6. What is the ratio of the Value added (% of GDP) of Mongolia in 2004 to that in 2006?
Provide a short and direct response. 0.74. What is the ratio of the Value added (% of GDP) in Ethiopia in 2004 to that in 2007?
Keep it short and to the point. 1.11. What is the ratio of the Value added (% of GDP) of Greece in 2004 to that in 2007?
Make the answer very short. 1.11. What is the ratio of the Value added (% of GDP) of Mauritania in 2004 to that in 2007?
Offer a terse response. 0.7. What is the ratio of the Value added (% of GDP) of Mongolia in 2004 to that in 2007?
Provide a short and direct response. 0.76. What is the ratio of the Value added (% of GDP) of Ethiopia in 2004 to that in 2008?
Provide a succinct answer. 1.27. What is the ratio of the Value added (% of GDP) in Greece in 2004 to that in 2008?
Keep it short and to the point. 1.27. What is the ratio of the Value added (% of GDP) of Mauritania in 2004 to that in 2008?
Provide a succinct answer. 0.7. What is the ratio of the Value added (% of GDP) of Mongolia in 2004 to that in 2008?
Provide a short and direct response. 0.93. What is the ratio of the Value added (% of GDP) in Ethiopia in 2004 to that in 2009?
Ensure brevity in your answer.  1.35. What is the ratio of the Value added (% of GDP) of Greece in 2004 to that in 2009?
Provide a short and direct response. 1.32. What is the ratio of the Value added (% of GDP) in Mauritania in 2004 to that in 2009?
Give a very brief answer. 0.78. What is the ratio of the Value added (% of GDP) in Mongolia in 2004 to that in 2009?
Your answer should be compact. 0.97. What is the ratio of the Value added (% of GDP) of Ethiopia in 2004 to that in 2010?
Offer a very short reply. 1.36. What is the ratio of the Value added (% of GDP) in Greece in 2004 to that in 2010?
Your response must be concise. 1.44. What is the ratio of the Value added (% of GDP) in Mauritania in 2004 to that in 2010?
Provide a short and direct response. 0.67. What is the ratio of the Value added (% of GDP) of Mongolia in 2004 to that in 2010?
Give a very brief answer. 0.86. What is the ratio of the Value added (% of GDP) of Ethiopia in 2005 to that in 2006?
Your answer should be compact. 1.02. What is the ratio of the Value added (% of GDP) of Greece in 2005 to that in 2006?
Make the answer very short. 0.88. What is the ratio of the Value added (% of GDP) of Mauritania in 2005 to that in 2006?
Your answer should be very brief. 0.71. What is the ratio of the Value added (% of GDP) of Mongolia in 2005 to that in 2006?
Provide a short and direct response. 0.84. What is the ratio of the Value added (% of GDP) of Ethiopia in 2005 to that in 2007?
Your response must be concise. 1.03. What is the ratio of the Value added (% of GDP) of Greece in 2005 to that in 2007?
Ensure brevity in your answer.  0.97. What is the ratio of the Value added (% of GDP) of Mauritania in 2005 to that in 2007?
Your answer should be very brief. 0.84. What is the ratio of the Value added (% of GDP) of Mongolia in 2005 to that in 2007?
Your answer should be compact. 0.86. What is the ratio of the Value added (% of GDP) of Ethiopia in 2005 to that in 2008?
Your answer should be compact. 1.17. What is the ratio of the Value added (% of GDP) of Greece in 2005 to that in 2008?
Your response must be concise. 1.12. What is the ratio of the Value added (% of GDP) of Mauritania in 2005 to that in 2008?
Your response must be concise. 0.84. What is the ratio of the Value added (% of GDP) of Mongolia in 2005 to that in 2008?
Ensure brevity in your answer.  1.05. What is the ratio of the Value added (% of GDP) of Ethiopia in 2005 to that in 2009?
Ensure brevity in your answer.  1.25. What is the ratio of the Value added (% of GDP) in Greece in 2005 to that in 2009?
Make the answer very short. 1.16. What is the ratio of the Value added (% of GDP) of Mauritania in 2005 to that in 2009?
Offer a terse response. 0.93. What is the ratio of the Value added (% of GDP) in Mongolia in 2005 to that in 2009?
Provide a short and direct response. 1.1. What is the ratio of the Value added (% of GDP) of Ethiopia in 2005 to that in 2010?
Offer a terse response. 1.26. What is the ratio of the Value added (% of GDP) of Greece in 2005 to that in 2010?
Make the answer very short. 1.27. What is the ratio of the Value added (% of GDP) in Mauritania in 2005 to that in 2010?
Your answer should be very brief. 0.79. What is the ratio of the Value added (% of GDP) of Mongolia in 2005 to that in 2010?
Your answer should be very brief. 0.98. What is the ratio of the Value added (% of GDP) in Ethiopia in 2006 to that in 2007?
Your answer should be very brief. 1. What is the ratio of the Value added (% of GDP) in Greece in 2006 to that in 2007?
Make the answer very short. 1.11. What is the ratio of the Value added (% of GDP) of Mauritania in 2006 to that in 2007?
Make the answer very short. 1.18. What is the ratio of the Value added (% of GDP) of Ethiopia in 2006 to that in 2008?
Make the answer very short. 1.14. What is the ratio of the Value added (% of GDP) in Greece in 2006 to that in 2008?
Make the answer very short. 1.27. What is the ratio of the Value added (% of GDP) of Mauritania in 2006 to that in 2008?
Your answer should be very brief. 1.18. What is the ratio of the Value added (% of GDP) in Mongolia in 2006 to that in 2008?
Give a very brief answer. 1.25. What is the ratio of the Value added (% of GDP) of Ethiopia in 2006 to that in 2009?
Make the answer very short. 1.22. What is the ratio of the Value added (% of GDP) in Greece in 2006 to that in 2009?
Offer a terse response. 1.32. What is the ratio of the Value added (% of GDP) in Mauritania in 2006 to that in 2009?
Ensure brevity in your answer.  1.32. What is the ratio of the Value added (% of GDP) in Mongolia in 2006 to that in 2009?
Your answer should be very brief. 1.3. What is the ratio of the Value added (% of GDP) of Ethiopia in 2006 to that in 2010?
Provide a succinct answer. 1.23. What is the ratio of the Value added (% of GDP) of Greece in 2006 to that in 2010?
Make the answer very short. 1.44. What is the ratio of the Value added (% of GDP) of Mauritania in 2006 to that in 2010?
Your answer should be very brief. 1.12. What is the ratio of the Value added (% of GDP) in Mongolia in 2006 to that in 2010?
Your response must be concise. 1.16. What is the ratio of the Value added (% of GDP) in Ethiopia in 2007 to that in 2008?
Keep it short and to the point. 1.14. What is the ratio of the Value added (% of GDP) of Greece in 2007 to that in 2008?
Ensure brevity in your answer.  1.15. What is the ratio of the Value added (% of GDP) in Mauritania in 2007 to that in 2008?
Offer a terse response. 1. What is the ratio of the Value added (% of GDP) of Mongolia in 2007 to that in 2008?
Keep it short and to the point. 1.22. What is the ratio of the Value added (% of GDP) of Ethiopia in 2007 to that in 2009?
Offer a terse response. 1.21. What is the ratio of the Value added (% of GDP) of Greece in 2007 to that in 2009?
Your answer should be compact. 1.19. What is the ratio of the Value added (% of GDP) in Mauritania in 2007 to that in 2009?
Ensure brevity in your answer.  1.12. What is the ratio of the Value added (% of GDP) of Mongolia in 2007 to that in 2009?
Provide a short and direct response. 1.27. What is the ratio of the Value added (% of GDP) in Ethiopia in 2007 to that in 2010?
Provide a succinct answer. 1.22. What is the ratio of the Value added (% of GDP) of Greece in 2007 to that in 2010?
Your answer should be very brief. 1.3. What is the ratio of the Value added (% of GDP) of Mauritania in 2007 to that in 2010?
Your response must be concise. 0.95. What is the ratio of the Value added (% of GDP) in Mongolia in 2007 to that in 2010?
Give a very brief answer. 1.13. What is the ratio of the Value added (% of GDP) in Ethiopia in 2008 to that in 2009?
Ensure brevity in your answer.  1.07. What is the ratio of the Value added (% of GDP) of Greece in 2008 to that in 2009?
Provide a short and direct response. 1.03. What is the ratio of the Value added (% of GDP) of Mauritania in 2008 to that in 2009?
Your response must be concise. 1.11. What is the ratio of the Value added (% of GDP) in Mongolia in 2008 to that in 2009?
Provide a short and direct response. 1.04. What is the ratio of the Value added (% of GDP) in Ethiopia in 2008 to that in 2010?
Provide a short and direct response. 1.07. What is the ratio of the Value added (% of GDP) of Greece in 2008 to that in 2010?
Keep it short and to the point. 1.13. What is the ratio of the Value added (% of GDP) of Mauritania in 2008 to that in 2010?
Offer a very short reply. 0.95. What is the ratio of the Value added (% of GDP) of Mongolia in 2008 to that in 2010?
Make the answer very short. 0.93. What is the ratio of the Value added (% of GDP) in Greece in 2009 to that in 2010?
Keep it short and to the point. 1.09. What is the ratio of the Value added (% of GDP) in Mauritania in 2009 to that in 2010?
Your answer should be compact. 0.85. What is the ratio of the Value added (% of GDP) in Mongolia in 2009 to that in 2010?
Offer a very short reply. 0.89. What is the difference between the highest and the second highest Value added (% of GDP) in Ethiopia?
Offer a very short reply. 0.01. What is the difference between the highest and the second highest Value added (% of GDP) in Greece?
Give a very brief answer. 0.31. What is the difference between the highest and the second highest Value added (% of GDP) of Mauritania?
Ensure brevity in your answer.  4.97. What is the difference between the highest and the second highest Value added (% of GDP) of Mongolia?
Give a very brief answer. 1.13. What is the difference between the highest and the lowest Value added (% of GDP) of Ethiopia?
Your response must be concise. 3.7. What is the difference between the highest and the lowest Value added (% of GDP) in Greece?
Offer a terse response. 7.21. What is the difference between the highest and the lowest Value added (% of GDP) of Mauritania?
Offer a terse response. 22.22. What is the difference between the highest and the lowest Value added (% of GDP) in Mongolia?
Provide a short and direct response. 14.62. 